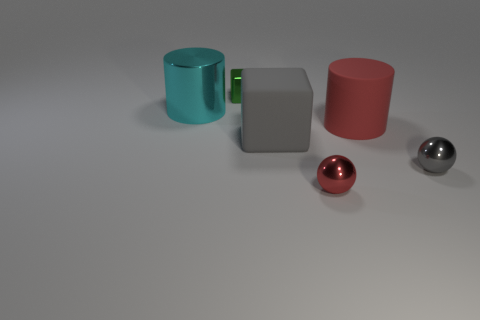Are there more large gray matte objects behind the green metallic thing than rubber cylinders that are right of the red matte object?
Keep it short and to the point. No. How many other objects are the same size as the gray ball?
Offer a terse response. 2. There is a small gray metallic thing; does it have the same shape as the tiny thing behind the big metallic cylinder?
Your answer should be compact. No. What number of matte things are either tiny spheres or tiny red things?
Your answer should be compact. 0. Is there a cylinder that has the same color as the big matte cube?
Your answer should be very brief. No. Are any rubber cylinders visible?
Make the answer very short. Yes. Is the shape of the green shiny object the same as the large cyan object?
Your answer should be compact. No. What number of large objects are either green objects or cyan balls?
Offer a very short reply. 0. The matte cube has what color?
Your response must be concise. Gray. There is a small object that is behind the matte object in front of the big red matte cylinder; what is its shape?
Keep it short and to the point. Cube. 